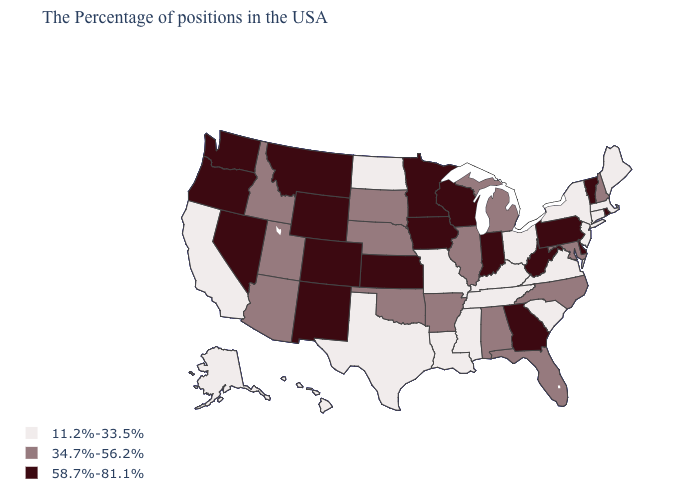Does Alabama have a higher value than Kentucky?
Answer briefly. Yes. Name the states that have a value in the range 58.7%-81.1%?
Keep it brief. Rhode Island, Vermont, Delaware, Pennsylvania, West Virginia, Georgia, Indiana, Wisconsin, Minnesota, Iowa, Kansas, Wyoming, Colorado, New Mexico, Montana, Nevada, Washington, Oregon. Name the states that have a value in the range 11.2%-33.5%?
Short answer required. Maine, Massachusetts, Connecticut, New York, New Jersey, Virginia, South Carolina, Ohio, Kentucky, Tennessee, Mississippi, Louisiana, Missouri, Texas, North Dakota, California, Alaska, Hawaii. What is the value of Maine?
Write a very short answer. 11.2%-33.5%. What is the value of Illinois?
Keep it brief. 34.7%-56.2%. What is the value of Colorado?
Concise answer only. 58.7%-81.1%. Among the states that border Connecticut , does Rhode Island have the highest value?
Concise answer only. Yes. Which states have the lowest value in the USA?
Be succinct. Maine, Massachusetts, Connecticut, New York, New Jersey, Virginia, South Carolina, Ohio, Kentucky, Tennessee, Mississippi, Louisiana, Missouri, Texas, North Dakota, California, Alaska, Hawaii. Does New Mexico have the lowest value in the USA?
Concise answer only. No. Does Louisiana have the lowest value in the USA?
Answer briefly. Yes. Does Colorado have the highest value in the West?
Short answer required. Yes. Does the first symbol in the legend represent the smallest category?
Short answer required. Yes. Does New Mexico have the lowest value in the USA?
Quick response, please. No. Among the states that border Connecticut , which have the highest value?
Answer briefly. Rhode Island. Name the states that have a value in the range 11.2%-33.5%?
Give a very brief answer. Maine, Massachusetts, Connecticut, New York, New Jersey, Virginia, South Carolina, Ohio, Kentucky, Tennessee, Mississippi, Louisiana, Missouri, Texas, North Dakota, California, Alaska, Hawaii. 